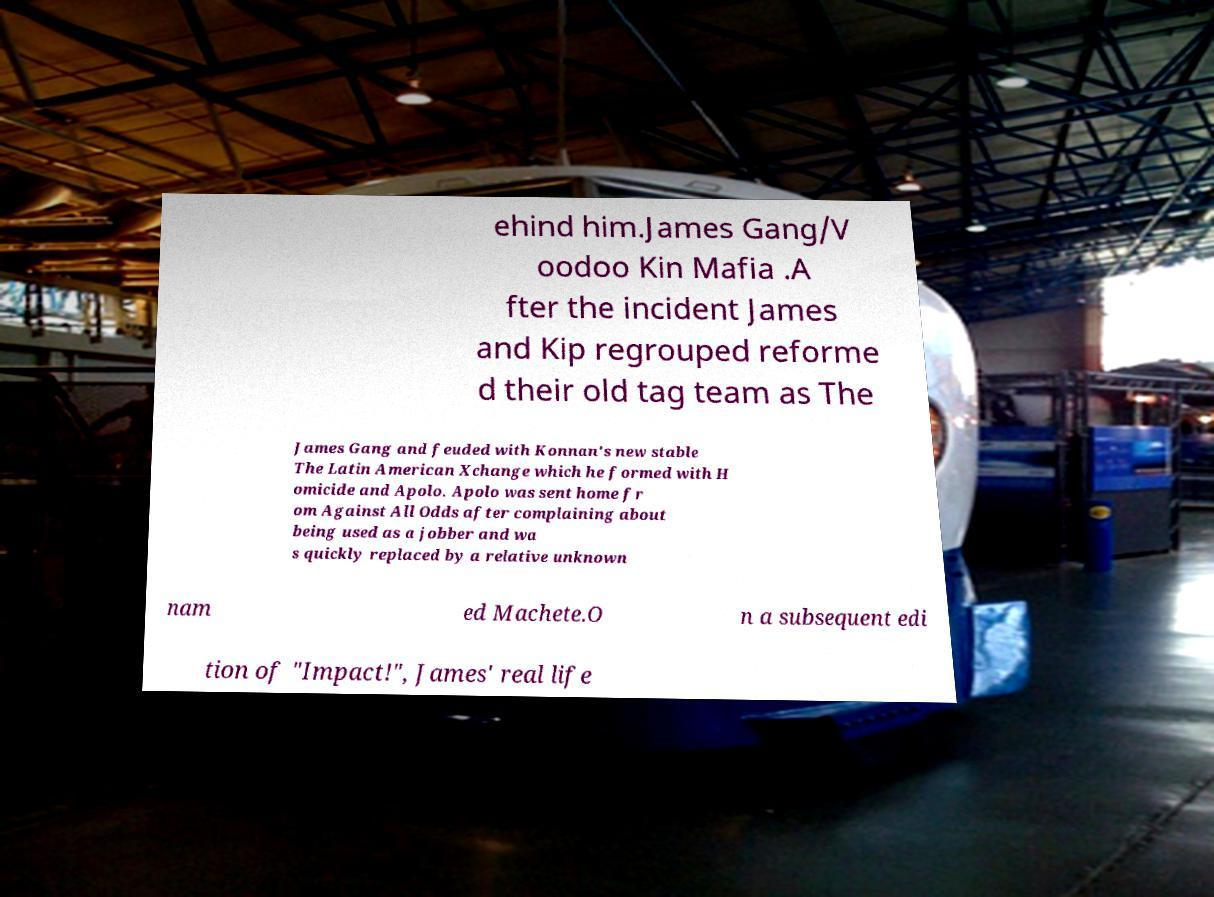Can you accurately transcribe the text from the provided image for me? ehind him.James Gang/V oodoo Kin Mafia .A fter the incident James and Kip regrouped reforme d their old tag team as The James Gang and feuded with Konnan's new stable The Latin American Xchange which he formed with H omicide and Apolo. Apolo was sent home fr om Against All Odds after complaining about being used as a jobber and wa s quickly replaced by a relative unknown nam ed Machete.O n a subsequent edi tion of "Impact!", James' real life 